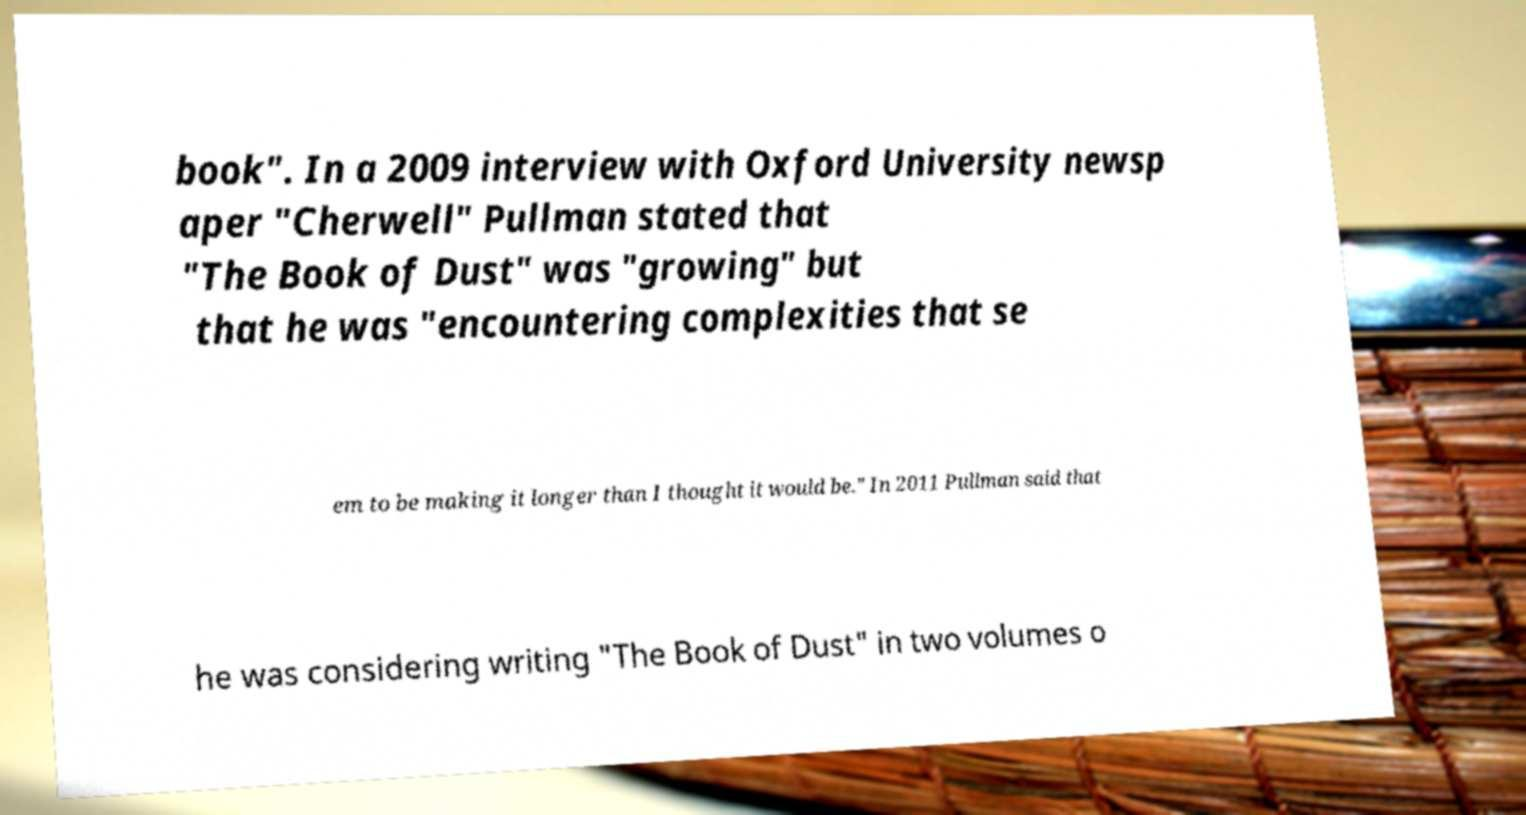Could you extract and type out the text from this image? book". In a 2009 interview with Oxford University newsp aper "Cherwell" Pullman stated that "The Book of Dust" was "growing" but that he was "encountering complexities that se em to be making it longer than I thought it would be." In 2011 Pullman said that he was considering writing "The Book of Dust" in two volumes o 